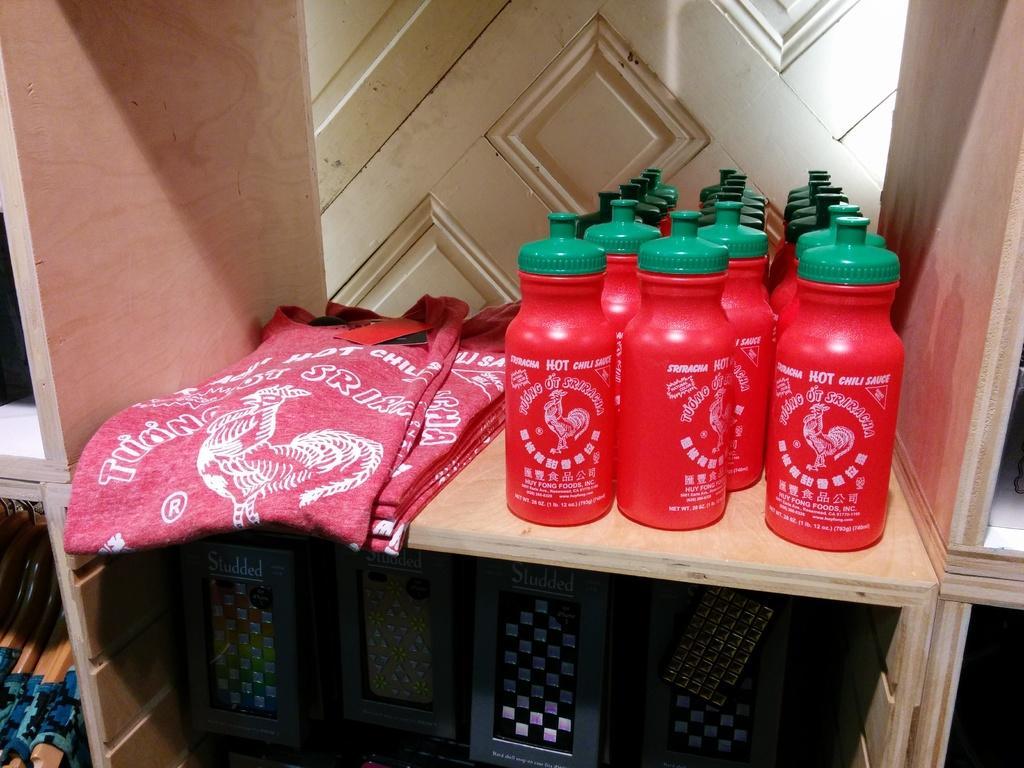Please provide a concise description of this image. In this image we can see t shirts, hot chili sauce bottles and also some studded boxes placed on the wooden racks. We can also see the closet. 